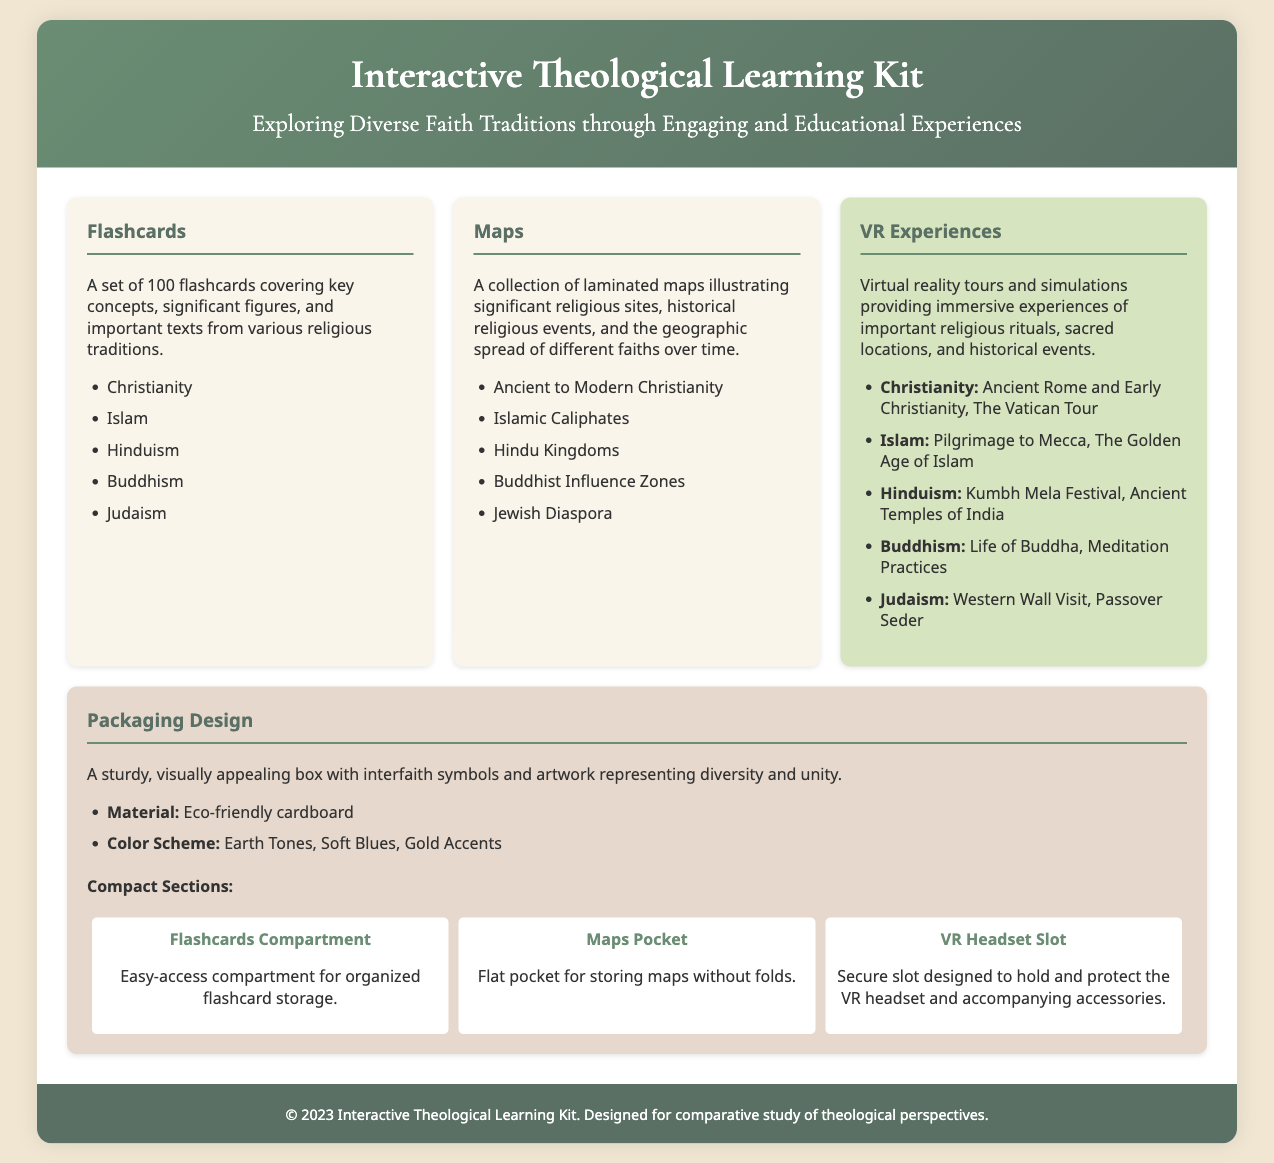What are the key materials included in the kit? The document lists flashcards, maps, and VR experiences as the key materials included in the kit.
Answer: Flashcards, maps, and VR experiences How many flashcards are included? The document specifies that there is a set of 100 flashcards covering various concepts.
Answer: 100 What religious traditions are covered by the flashcards? The flashcards cover five specified religious traditions listed in the document.
Answer: Christianity, Islam, Hinduism, Buddhism, Judaism What is the packaging material made of? The document states that the packaging is made of eco-friendly cardboard.
Answer: Eco-friendly cardboard Which VR experience focuses on the Kumbh Mela Festival? The document indicates that the VR experience focusing on the Kumbh Mela Festival is part of Hinduism.
Answer: Hinduism What colors are featured in the packaging design? The document outlines that the color scheme for the packaging includes earth tones, soft blues, and gold accents.
Answer: Earth Tones, Soft Blues, Gold Accents How is the flashcard compartment designed in the packaging? The document describes the flashcard compartment as being designed for easy access to organized flashcard storage.
Answer: Easy-access compartment What does the design highlight about the interfaith symbols? The document emphasizes that the packaging features interfaith symbols representing diversity and unity.
Answer: Diversity and unity 